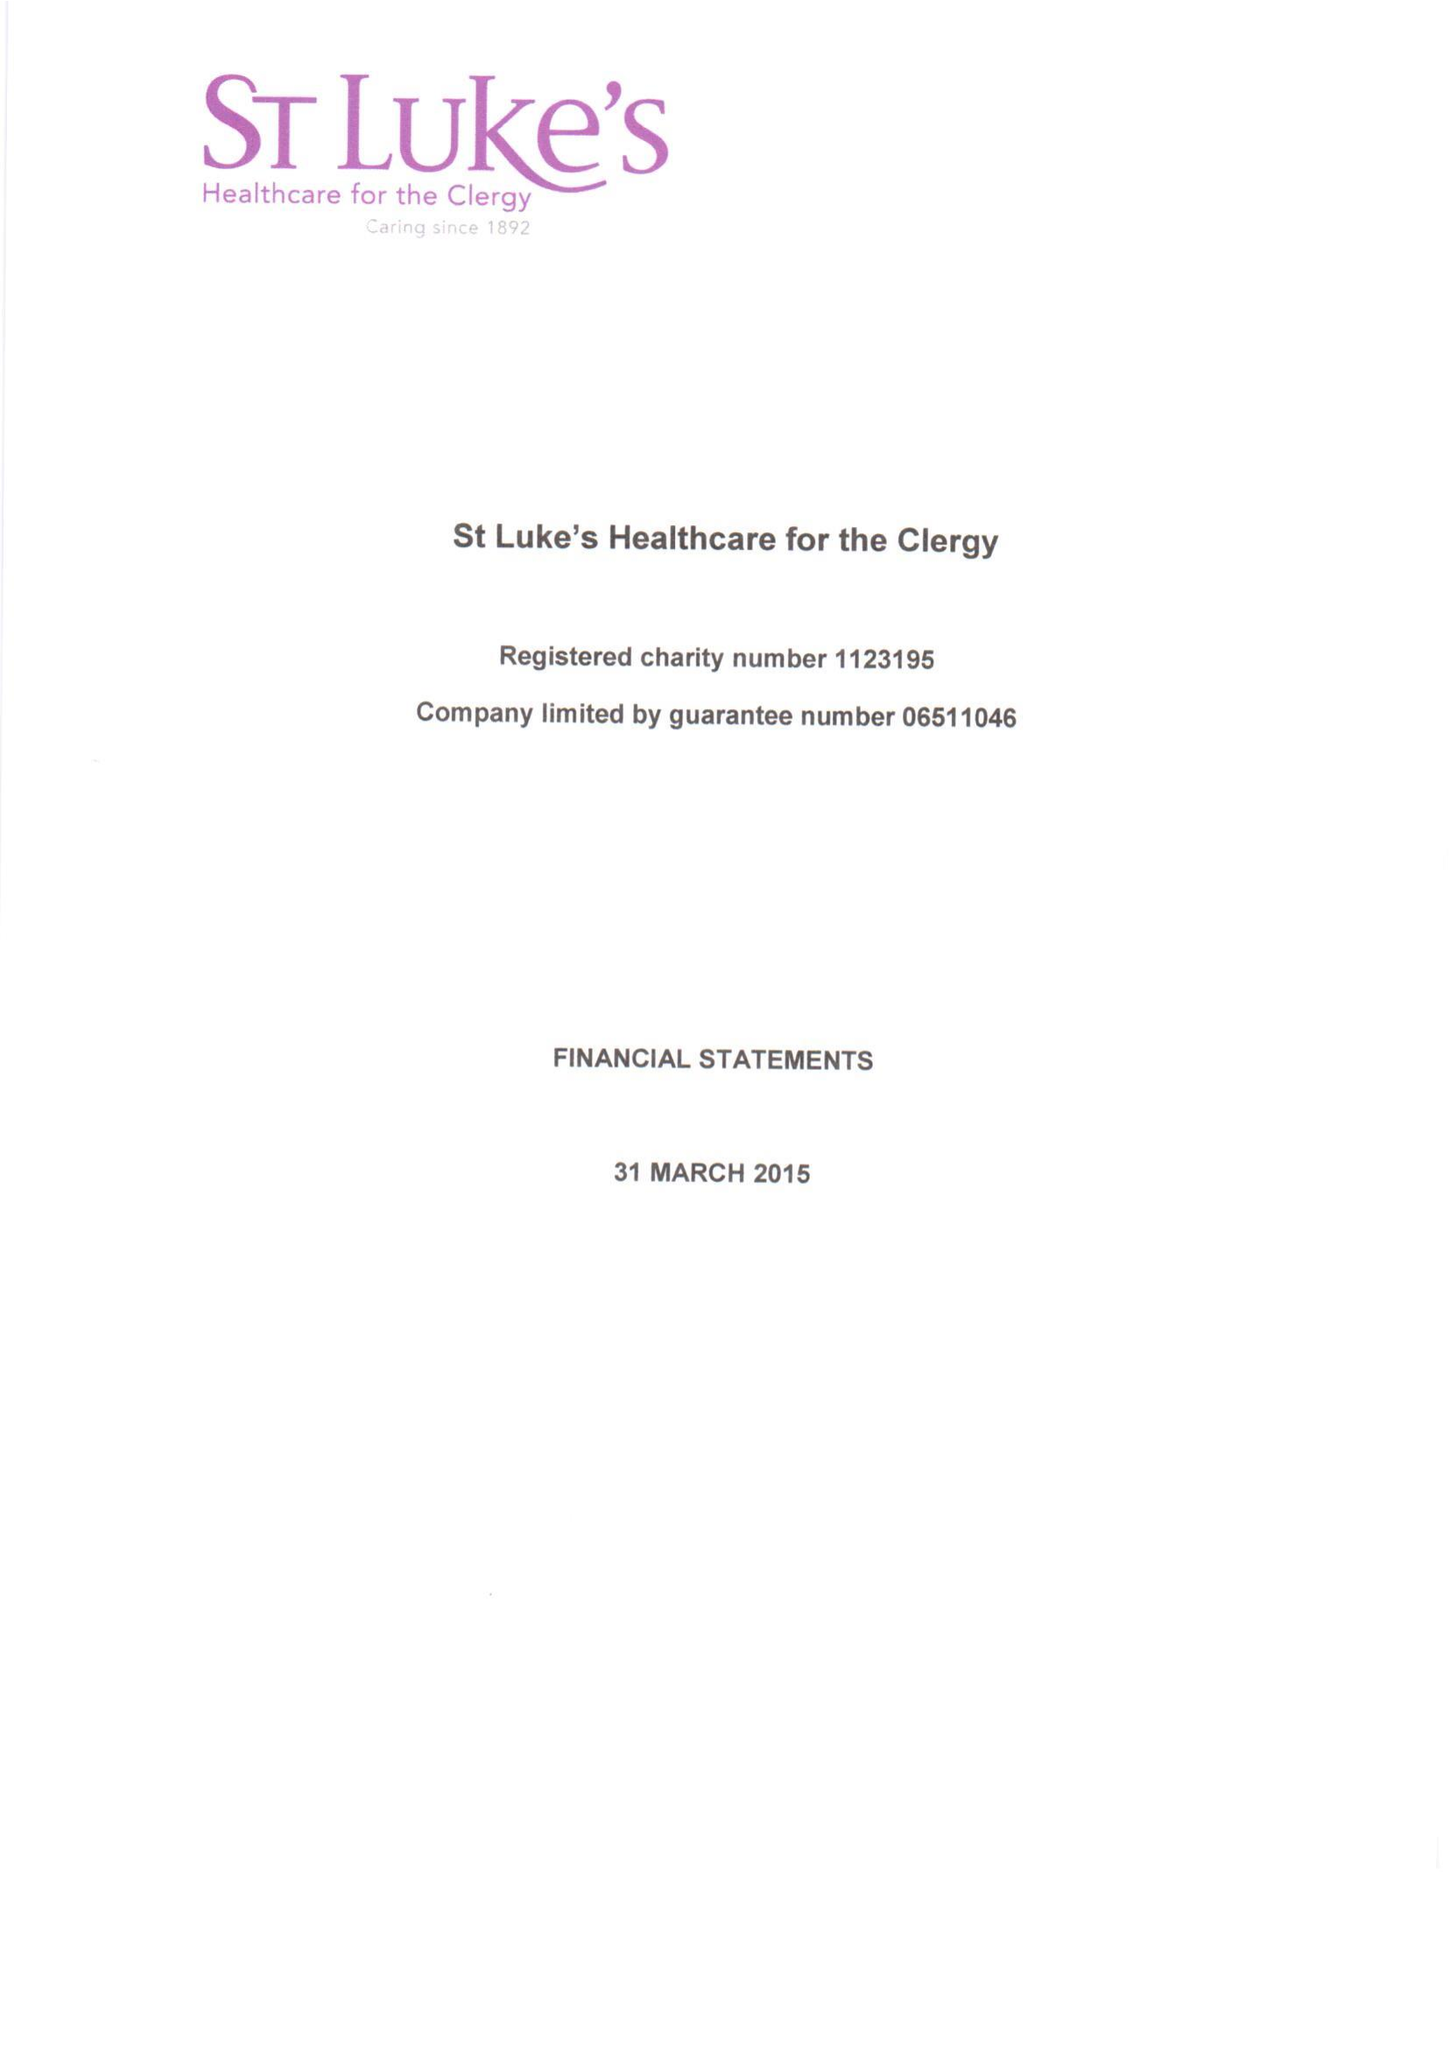What is the value for the charity_name?
Answer the question using a single word or phrase. St Luke's Healthcare For The Clergy 